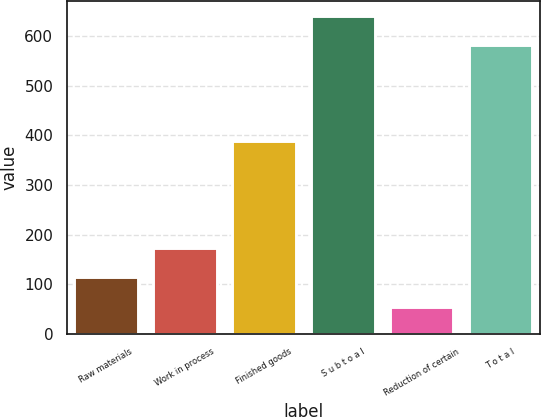Convert chart. <chart><loc_0><loc_0><loc_500><loc_500><bar_chart><fcel>Raw materials<fcel>Work in process<fcel>Finished goods<fcel>S u b t o a l<fcel>Reduction of certain<fcel>T o t a l<nl><fcel>114.6<fcel>172.77<fcel>389<fcel>639.87<fcel>54.1<fcel>581.7<nl></chart> 